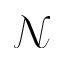<formula> <loc_0><loc_0><loc_500><loc_500>\mathcal { N }</formula> 